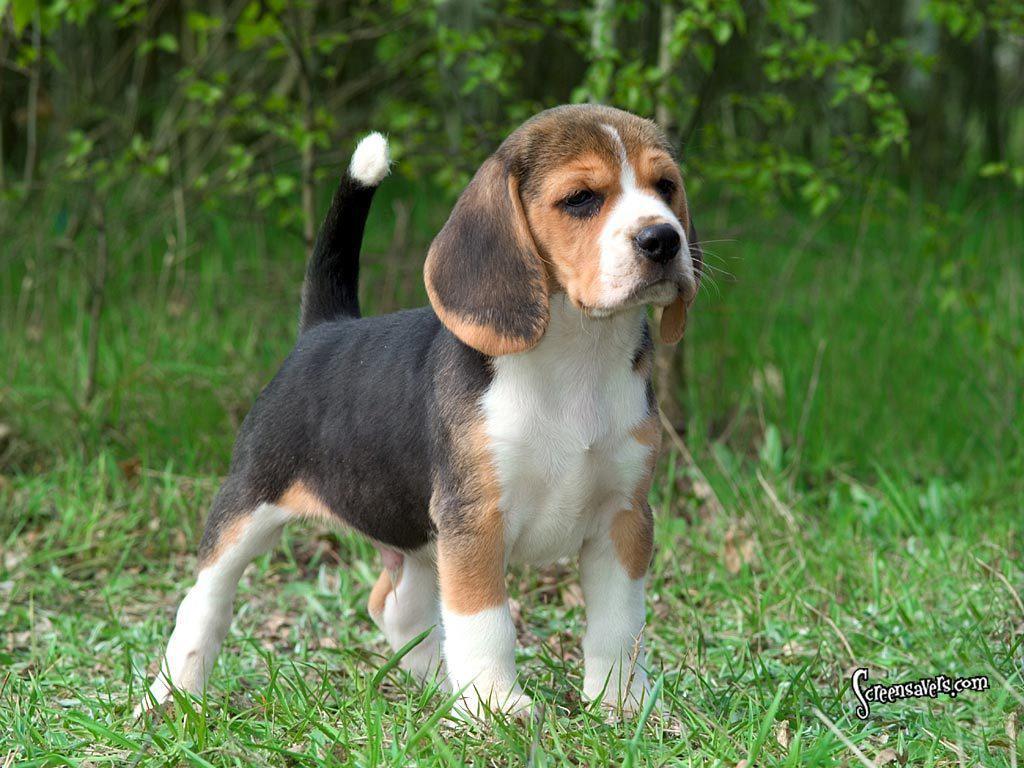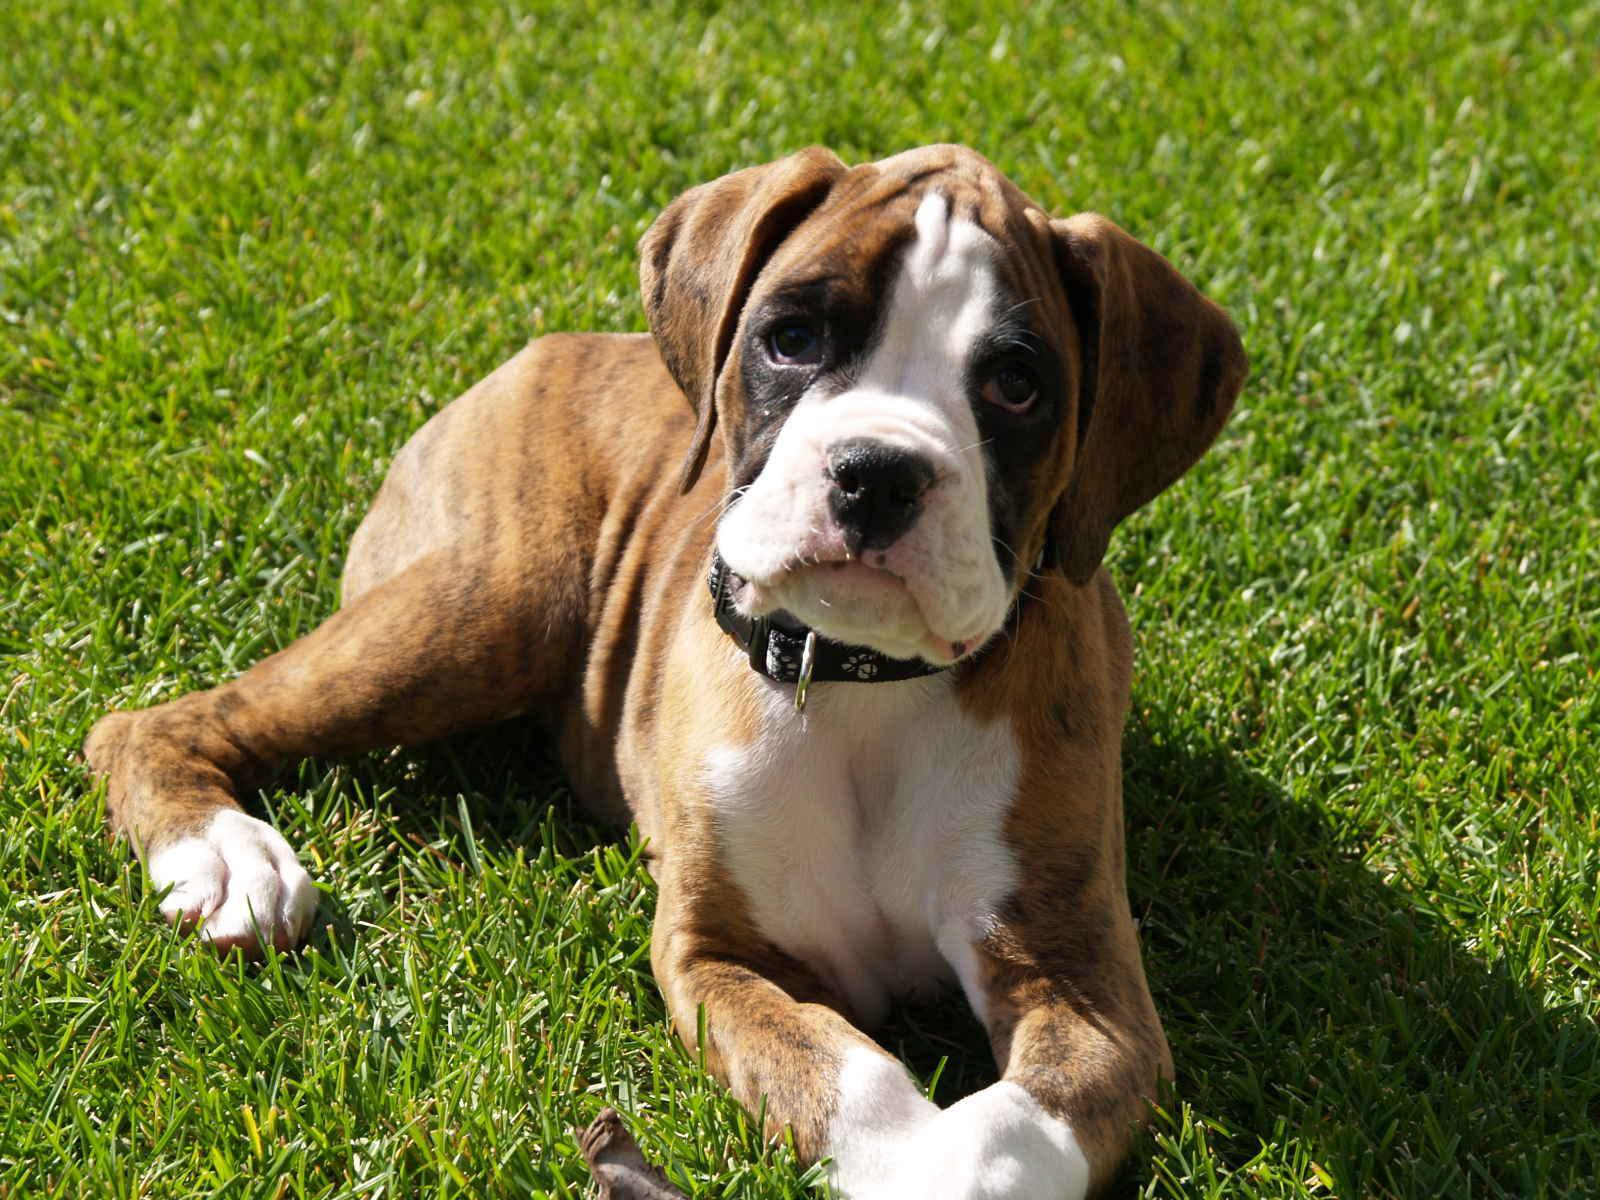The first image is the image on the left, the second image is the image on the right. Examine the images to the left and right. Is the description "A floppy eared dog is moving forward across the grass in one image." accurate? Answer yes or no. No. The first image is the image on the left, the second image is the image on the right. For the images displayed, is the sentence "the dog appears to be moving in one of the images" factually correct? Answer yes or no. No. 